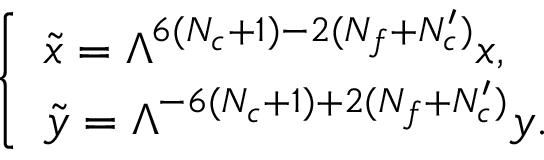Convert formula to latex. <formula><loc_0><loc_0><loc_500><loc_500>\left \{ \begin{array} { l } { { \tilde { x } = \Lambda ^ { 6 ( N _ { c } + 1 ) - 2 ( N _ { f } + N _ { c } ^ { \prime } ) } x , } } \\ { { \tilde { y } = \Lambda ^ { - 6 ( N _ { c } + 1 ) + 2 ( N _ { f } + N _ { c } ^ { \prime } ) } y . } } \end{array}</formula> 